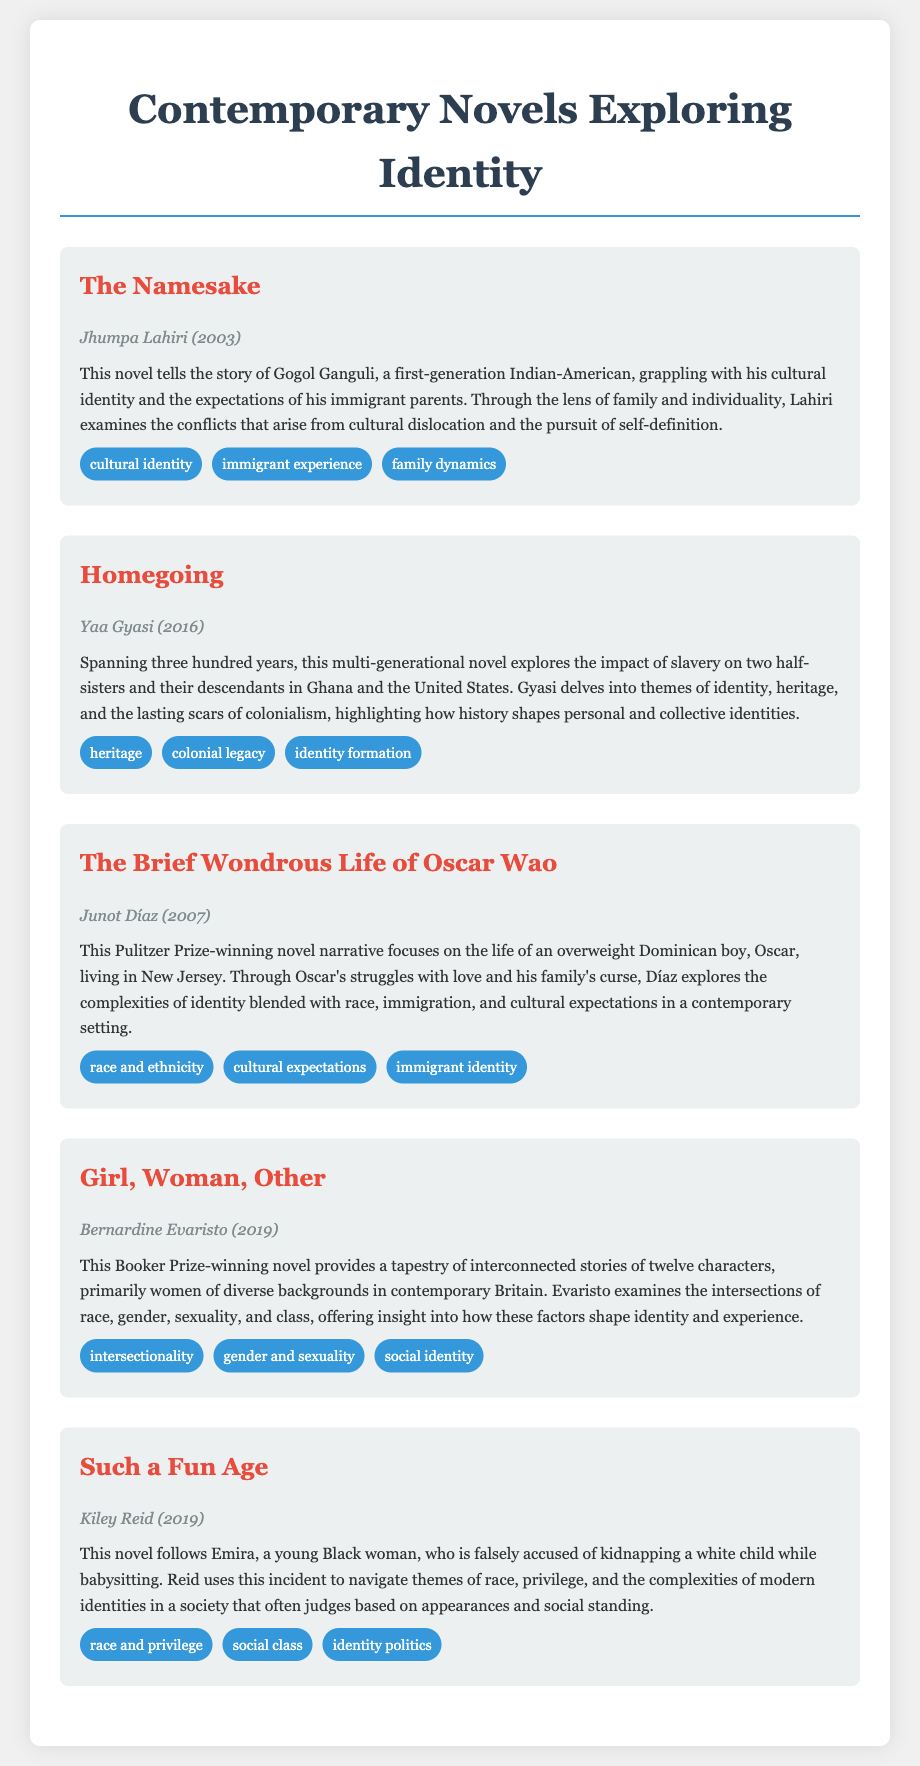What is the title of Jhumpa Lahiri's novel? The title of the novel by Jhumpa Lahiri mentioned in the document is "The Namesake."
Answer: The Namesake Which award did "Girl, Woman, Other" win? The document states that "Girl, Woman, Other" won the Booker Prize.
Answer: Booker Prize How many books are listed in the bibliography? The document provides a total of five contemporary novels exploring identity.
Answer: Five What is a key theme in "Homegoing"? The document highlights "heritage" as one of the key themes in "Homegoing."
Answer: Heritage Which author wrote "Such a Fun Age"? According to the document, Kiley Reid is the author of "Such a Fun Age."
Answer: Kiley Reid What cultural aspect does "The Brief Wondrous Life of Oscar Wao" explore? The document indicates that the novel explores themes of race and ethnicity.
Answer: Race and ethnicity What does "cultural identity" refer to in the context of "The Namesake"? In "The Namesake," "cultural identity" refers to the challenges faced by Gogol as a first-generation Indian-American.
Answer: Challenges faced by Gogol Which character's story is central to "Such a Fun Age"? The document specifies that the central character in "Such a Fun Age" is Emira.
Answer: Emira 